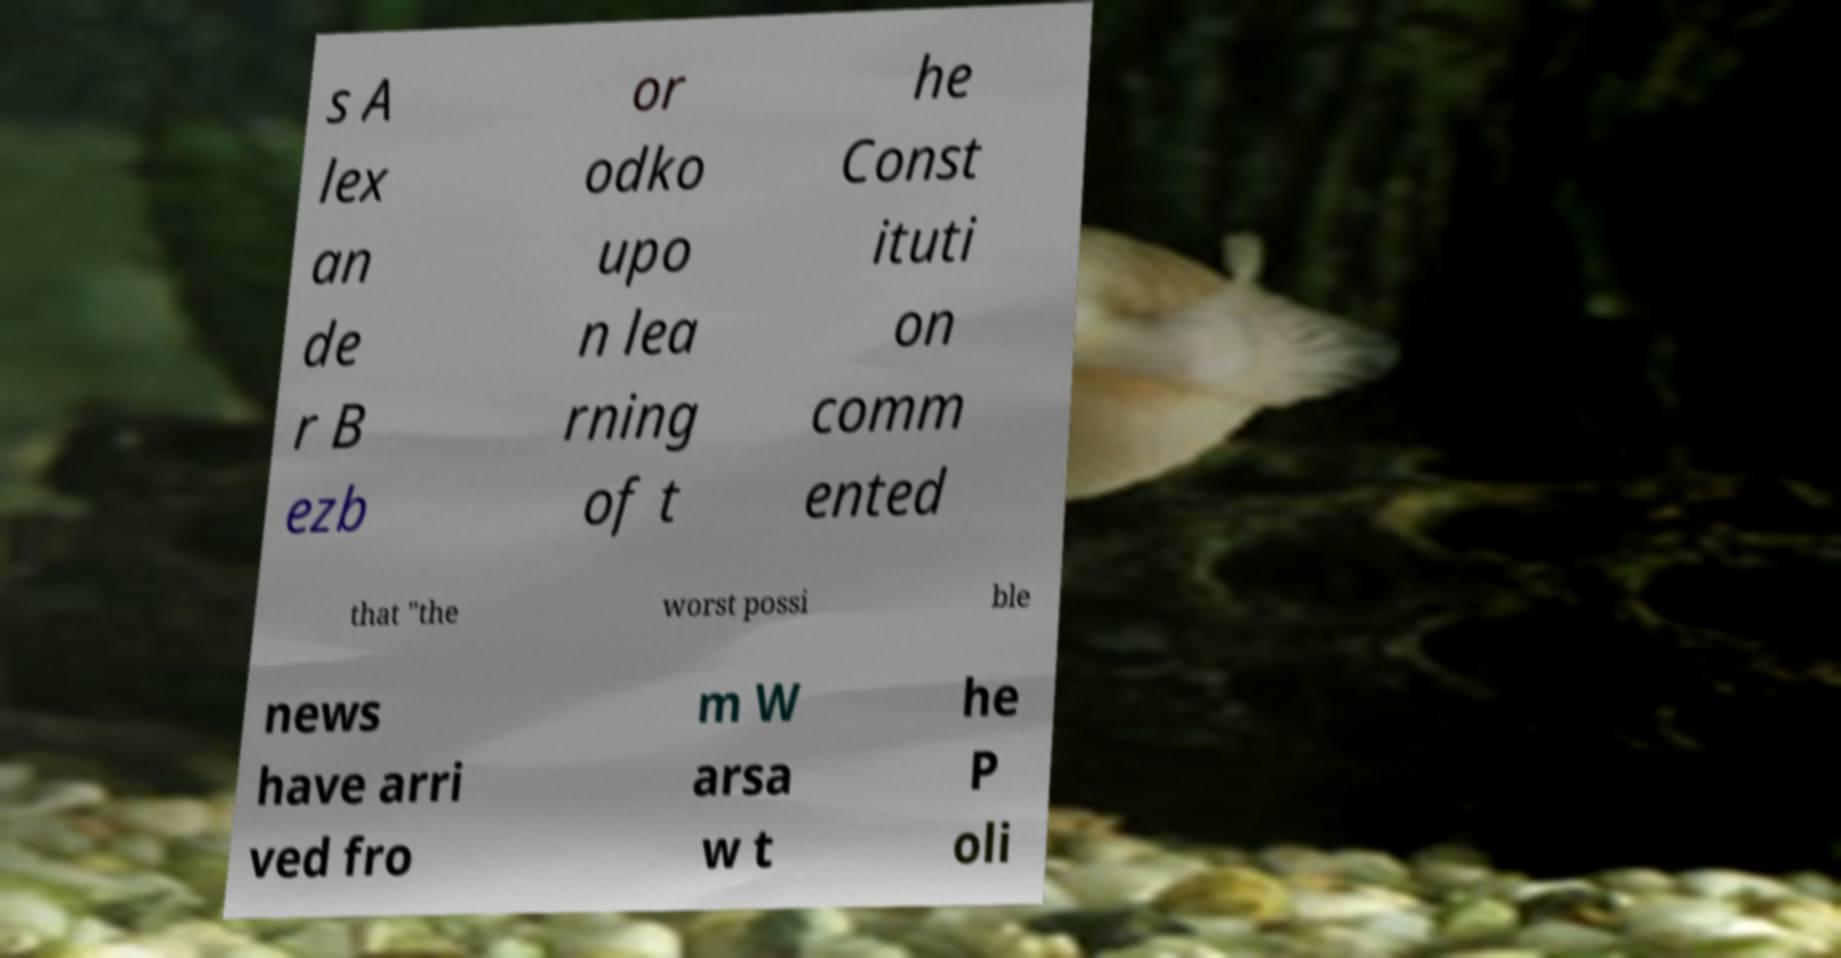Can you read and provide the text displayed in the image?This photo seems to have some interesting text. Can you extract and type it out for me? s A lex an de r B ezb or odko upo n lea rning of t he Const ituti on comm ented that "the worst possi ble news have arri ved fro m W arsa w t he P oli 